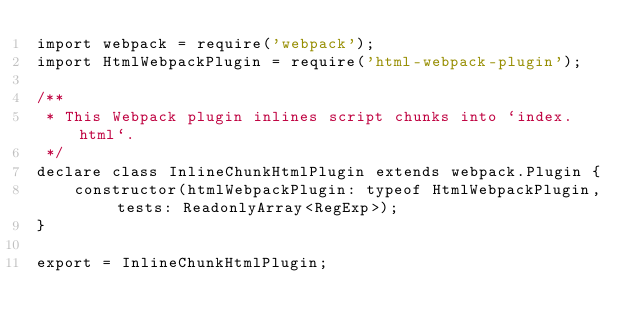<code> <loc_0><loc_0><loc_500><loc_500><_TypeScript_>import webpack = require('webpack');
import HtmlWebpackPlugin = require('html-webpack-plugin');

/**
 * This Webpack plugin inlines script chunks into `index.html`.
 */
declare class InlineChunkHtmlPlugin extends webpack.Plugin {
    constructor(htmlWebpackPlugin: typeof HtmlWebpackPlugin, tests: ReadonlyArray<RegExp>);
}

export = InlineChunkHtmlPlugin;
</code> 